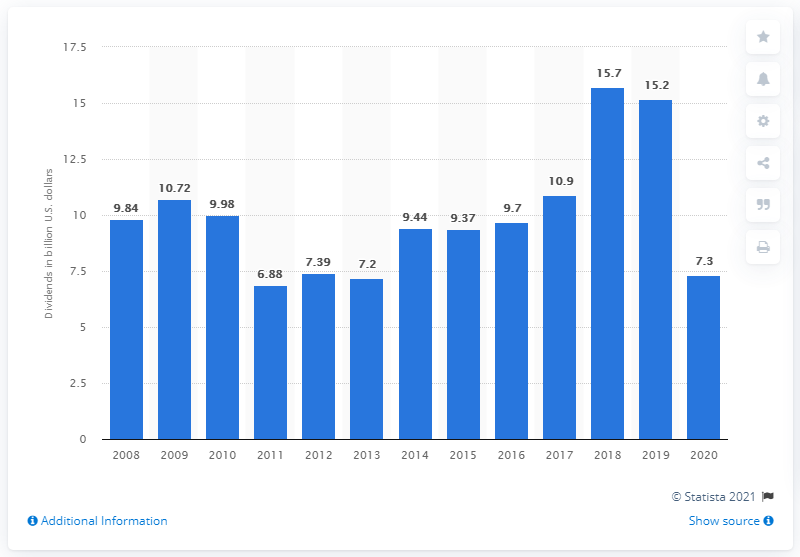Give some essential details in this illustration. In 2018, Royal Dutch Shell distributed a total of $15.7 billion in dividends to its shareholders. Royal Dutch Shell paid dividends of 7.3 billion US dollars in 2020. 